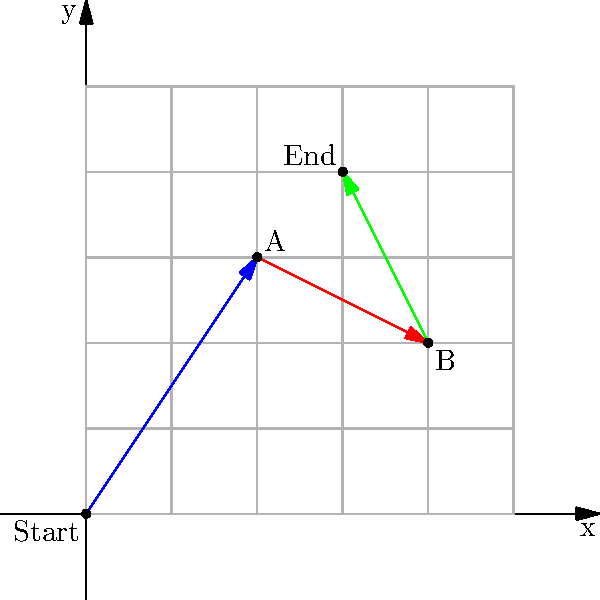In a strategy board game, a player moves their game piece from the origin (0, 0) through a series of three moves represented by vectors. The first move is $\vec{v_1} = \langle 2, 3 \rangle$, the second move is $\vec{v_2} = \langle 2, -1 \rangle$, and the third move is $\vec{v_3} = \langle -1, 2 \rangle$. What is the final position of the game piece after all three moves? Let's approach this step-by-step:

1) We start at the origin (0, 0).

2) The first move $\vec{v_1} = \langle 2, 3 \rangle$:
   - This moves the piece 2 units right and 3 units up.
   - New position: (2, 3)

3) The second move $\vec{v_2} = \langle 2, -1 \rangle$:
   - This moves the piece 2 units right and 1 unit down from the previous position.
   - New position: (2+2, 3-1) = (4, 2)

4) The third move $\vec{v_3} = \langle -1, 2 \rangle$:
   - This moves the piece 1 unit left and 2 units up from the previous position.
   - Final position: (4-1, 2+2) = (3, 4)

5) To verify, we can add all vectors:
   $\vec{v_1} + \vec{v_2} + \vec{v_3} = \langle 2, 3 \rangle + \langle 2, -1 \rangle + \langle -1, 2 \rangle$
   $= \langle 2+2-1, 3-1+2 \rangle = \langle 3, 4 \rangle$

Therefore, the final position of the game piece is (3, 4).
Answer: (3, 4) 